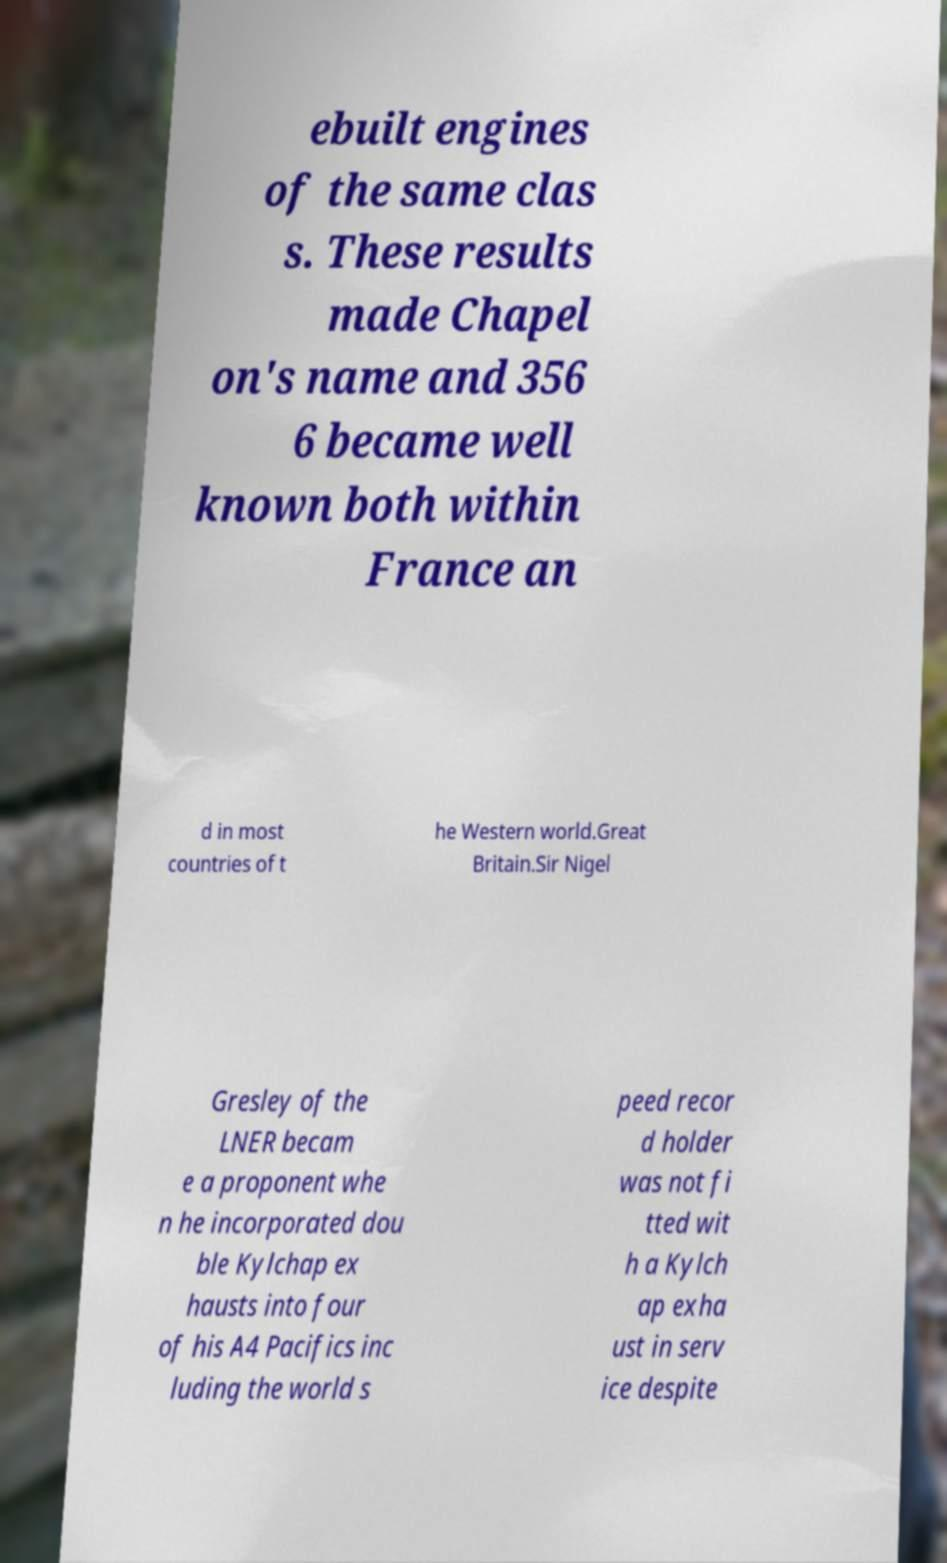There's text embedded in this image that I need extracted. Can you transcribe it verbatim? ebuilt engines of the same clas s. These results made Chapel on's name and 356 6 became well known both within France an d in most countries of t he Western world.Great Britain.Sir Nigel Gresley of the LNER becam e a proponent whe n he incorporated dou ble Kylchap ex hausts into four of his A4 Pacifics inc luding the world s peed recor d holder was not fi tted wit h a Kylch ap exha ust in serv ice despite 